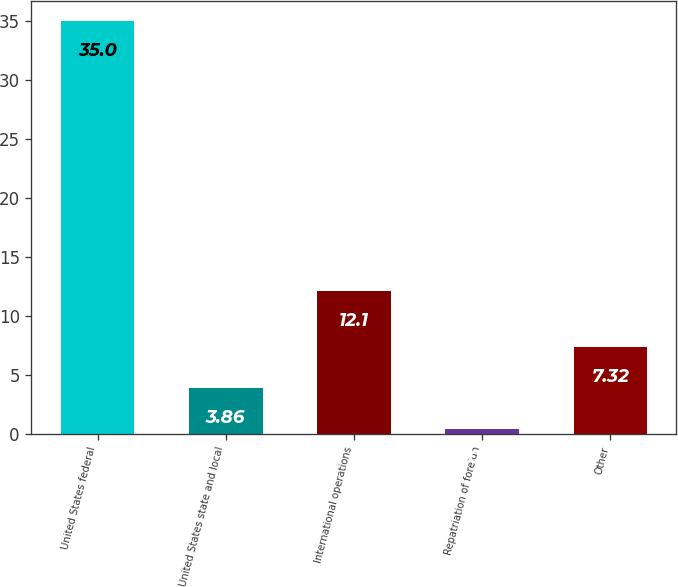Convert chart. <chart><loc_0><loc_0><loc_500><loc_500><bar_chart><fcel>United States federal<fcel>United States state and local<fcel>International operations<fcel>Repatriation of foreign<fcel>Other<nl><fcel>35<fcel>3.86<fcel>12.1<fcel>0.4<fcel>7.32<nl></chart> 